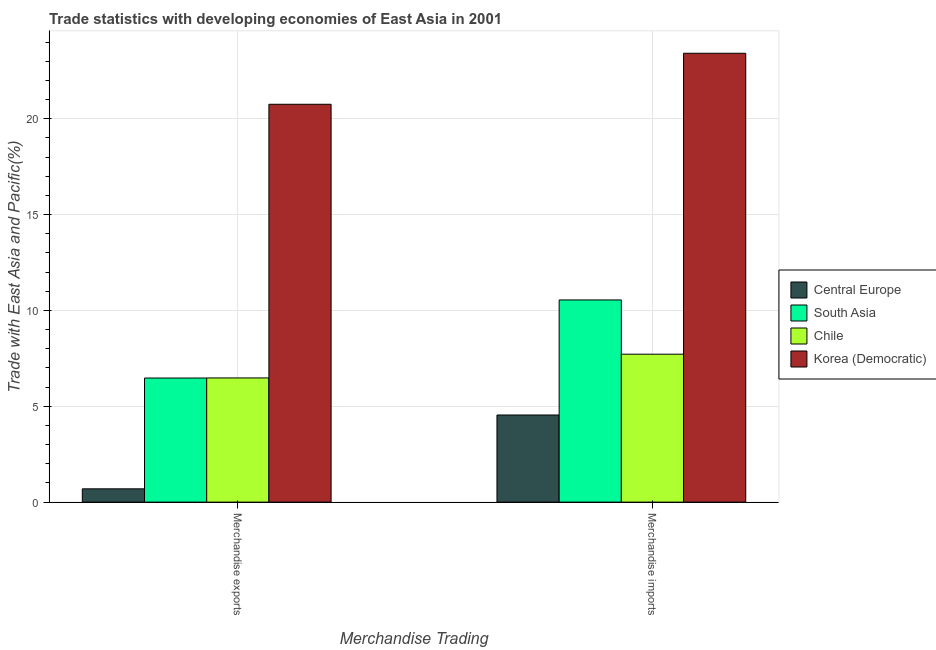Are the number of bars on each tick of the X-axis equal?
Your answer should be compact. Yes. How many bars are there on the 2nd tick from the left?
Make the answer very short. 4. How many bars are there on the 1st tick from the right?
Ensure brevity in your answer.  4. What is the merchandise imports in Chile?
Keep it short and to the point. 7.72. Across all countries, what is the maximum merchandise imports?
Offer a terse response. 23.42. Across all countries, what is the minimum merchandise exports?
Make the answer very short. 0.69. In which country was the merchandise exports maximum?
Your answer should be compact. Korea (Democratic). In which country was the merchandise imports minimum?
Provide a short and direct response. Central Europe. What is the total merchandise imports in the graph?
Offer a terse response. 46.22. What is the difference between the merchandise exports in South Asia and that in Central Europe?
Ensure brevity in your answer.  5.78. What is the difference between the merchandise exports in Central Europe and the merchandise imports in South Asia?
Provide a succinct answer. -9.85. What is the average merchandise exports per country?
Give a very brief answer. 8.6. What is the difference between the merchandise exports and merchandise imports in South Asia?
Ensure brevity in your answer.  -4.07. In how many countries, is the merchandise exports greater than 21 %?
Provide a succinct answer. 0. What is the ratio of the merchandise imports in Chile to that in Korea (Democratic)?
Your answer should be very brief. 0.33. Is the merchandise exports in Korea (Democratic) less than that in Chile?
Provide a succinct answer. No. In how many countries, is the merchandise exports greater than the average merchandise exports taken over all countries?
Provide a succinct answer. 1. What does the 1st bar from the right in Merchandise exports represents?
Offer a very short reply. Korea (Democratic). Are all the bars in the graph horizontal?
Your response must be concise. No. What is the difference between two consecutive major ticks on the Y-axis?
Ensure brevity in your answer.  5. Does the graph contain any zero values?
Give a very brief answer. No. Does the graph contain grids?
Ensure brevity in your answer.  Yes. Where does the legend appear in the graph?
Make the answer very short. Center right. How are the legend labels stacked?
Your answer should be very brief. Vertical. What is the title of the graph?
Offer a very short reply. Trade statistics with developing economies of East Asia in 2001. What is the label or title of the X-axis?
Make the answer very short. Merchandise Trading. What is the label or title of the Y-axis?
Offer a terse response. Trade with East Asia and Pacific(%). What is the Trade with East Asia and Pacific(%) in Central Europe in Merchandise exports?
Offer a very short reply. 0.69. What is the Trade with East Asia and Pacific(%) of South Asia in Merchandise exports?
Provide a short and direct response. 6.47. What is the Trade with East Asia and Pacific(%) in Chile in Merchandise exports?
Offer a terse response. 6.48. What is the Trade with East Asia and Pacific(%) of Korea (Democratic) in Merchandise exports?
Provide a short and direct response. 20.75. What is the Trade with East Asia and Pacific(%) in Central Europe in Merchandise imports?
Your response must be concise. 4.55. What is the Trade with East Asia and Pacific(%) in South Asia in Merchandise imports?
Ensure brevity in your answer.  10.55. What is the Trade with East Asia and Pacific(%) in Chile in Merchandise imports?
Make the answer very short. 7.72. What is the Trade with East Asia and Pacific(%) in Korea (Democratic) in Merchandise imports?
Make the answer very short. 23.42. Across all Merchandise Trading, what is the maximum Trade with East Asia and Pacific(%) in Central Europe?
Keep it short and to the point. 4.55. Across all Merchandise Trading, what is the maximum Trade with East Asia and Pacific(%) of South Asia?
Keep it short and to the point. 10.55. Across all Merchandise Trading, what is the maximum Trade with East Asia and Pacific(%) in Chile?
Your answer should be compact. 7.72. Across all Merchandise Trading, what is the maximum Trade with East Asia and Pacific(%) in Korea (Democratic)?
Your answer should be compact. 23.42. Across all Merchandise Trading, what is the minimum Trade with East Asia and Pacific(%) in Central Europe?
Your answer should be compact. 0.69. Across all Merchandise Trading, what is the minimum Trade with East Asia and Pacific(%) in South Asia?
Keep it short and to the point. 6.47. Across all Merchandise Trading, what is the minimum Trade with East Asia and Pacific(%) in Chile?
Offer a very short reply. 6.48. Across all Merchandise Trading, what is the minimum Trade with East Asia and Pacific(%) of Korea (Democratic)?
Your answer should be compact. 20.75. What is the total Trade with East Asia and Pacific(%) of Central Europe in the graph?
Offer a terse response. 5.24. What is the total Trade with East Asia and Pacific(%) in South Asia in the graph?
Your answer should be very brief. 17.02. What is the total Trade with East Asia and Pacific(%) of Chile in the graph?
Your answer should be very brief. 14.19. What is the total Trade with East Asia and Pacific(%) in Korea (Democratic) in the graph?
Give a very brief answer. 44.17. What is the difference between the Trade with East Asia and Pacific(%) in Central Europe in Merchandise exports and that in Merchandise imports?
Offer a very short reply. -3.85. What is the difference between the Trade with East Asia and Pacific(%) in South Asia in Merchandise exports and that in Merchandise imports?
Keep it short and to the point. -4.07. What is the difference between the Trade with East Asia and Pacific(%) in Chile in Merchandise exports and that in Merchandise imports?
Give a very brief answer. -1.24. What is the difference between the Trade with East Asia and Pacific(%) in Korea (Democratic) in Merchandise exports and that in Merchandise imports?
Offer a very short reply. -2.66. What is the difference between the Trade with East Asia and Pacific(%) of Central Europe in Merchandise exports and the Trade with East Asia and Pacific(%) of South Asia in Merchandise imports?
Make the answer very short. -9.85. What is the difference between the Trade with East Asia and Pacific(%) in Central Europe in Merchandise exports and the Trade with East Asia and Pacific(%) in Chile in Merchandise imports?
Offer a very short reply. -7.02. What is the difference between the Trade with East Asia and Pacific(%) of Central Europe in Merchandise exports and the Trade with East Asia and Pacific(%) of Korea (Democratic) in Merchandise imports?
Provide a short and direct response. -22.72. What is the difference between the Trade with East Asia and Pacific(%) in South Asia in Merchandise exports and the Trade with East Asia and Pacific(%) in Chile in Merchandise imports?
Your answer should be compact. -1.24. What is the difference between the Trade with East Asia and Pacific(%) in South Asia in Merchandise exports and the Trade with East Asia and Pacific(%) in Korea (Democratic) in Merchandise imports?
Provide a short and direct response. -16.94. What is the difference between the Trade with East Asia and Pacific(%) in Chile in Merchandise exports and the Trade with East Asia and Pacific(%) in Korea (Democratic) in Merchandise imports?
Offer a terse response. -16.94. What is the average Trade with East Asia and Pacific(%) in Central Europe per Merchandise Trading?
Your answer should be compact. 2.62. What is the average Trade with East Asia and Pacific(%) in South Asia per Merchandise Trading?
Ensure brevity in your answer.  8.51. What is the average Trade with East Asia and Pacific(%) in Chile per Merchandise Trading?
Provide a succinct answer. 7.1. What is the average Trade with East Asia and Pacific(%) of Korea (Democratic) per Merchandise Trading?
Give a very brief answer. 22.08. What is the difference between the Trade with East Asia and Pacific(%) in Central Europe and Trade with East Asia and Pacific(%) in South Asia in Merchandise exports?
Your answer should be compact. -5.78. What is the difference between the Trade with East Asia and Pacific(%) of Central Europe and Trade with East Asia and Pacific(%) of Chile in Merchandise exports?
Offer a very short reply. -5.78. What is the difference between the Trade with East Asia and Pacific(%) in Central Europe and Trade with East Asia and Pacific(%) in Korea (Democratic) in Merchandise exports?
Your answer should be compact. -20.06. What is the difference between the Trade with East Asia and Pacific(%) of South Asia and Trade with East Asia and Pacific(%) of Chile in Merchandise exports?
Your response must be concise. -0. What is the difference between the Trade with East Asia and Pacific(%) in South Asia and Trade with East Asia and Pacific(%) in Korea (Democratic) in Merchandise exports?
Offer a very short reply. -14.28. What is the difference between the Trade with East Asia and Pacific(%) of Chile and Trade with East Asia and Pacific(%) of Korea (Democratic) in Merchandise exports?
Your response must be concise. -14.28. What is the difference between the Trade with East Asia and Pacific(%) in Central Europe and Trade with East Asia and Pacific(%) in South Asia in Merchandise imports?
Offer a terse response. -6. What is the difference between the Trade with East Asia and Pacific(%) in Central Europe and Trade with East Asia and Pacific(%) in Chile in Merchandise imports?
Make the answer very short. -3.17. What is the difference between the Trade with East Asia and Pacific(%) in Central Europe and Trade with East Asia and Pacific(%) in Korea (Democratic) in Merchandise imports?
Make the answer very short. -18.87. What is the difference between the Trade with East Asia and Pacific(%) in South Asia and Trade with East Asia and Pacific(%) in Chile in Merchandise imports?
Your answer should be very brief. 2.83. What is the difference between the Trade with East Asia and Pacific(%) of South Asia and Trade with East Asia and Pacific(%) of Korea (Democratic) in Merchandise imports?
Provide a short and direct response. -12.87. What is the difference between the Trade with East Asia and Pacific(%) of Chile and Trade with East Asia and Pacific(%) of Korea (Democratic) in Merchandise imports?
Give a very brief answer. -15.7. What is the ratio of the Trade with East Asia and Pacific(%) in Central Europe in Merchandise exports to that in Merchandise imports?
Your answer should be compact. 0.15. What is the ratio of the Trade with East Asia and Pacific(%) in South Asia in Merchandise exports to that in Merchandise imports?
Provide a succinct answer. 0.61. What is the ratio of the Trade with East Asia and Pacific(%) in Chile in Merchandise exports to that in Merchandise imports?
Offer a very short reply. 0.84. What is the ratio of the Trade with East Asia and Pacific(%) of Korea (Democratic) in Merchandise exports to that in Merchandise imports?
Offer a very short reply. 0.89. What is the difference between the highest and the second highest Trade with East Asia and Pacific(%) of Central Europe?
Ensure brevity in your answer.  3.85. What is the difference between the highest and the second highest Trade with East Asia and Pacific(%) of South Asia?
Ensure brevity in your answer.  4.07. What is the difference between the highest and the second highest Trade with East Asia and Pacific(%) of Chile?
Your answer should be very brief. 1.24. What is the difference between the highest and the second highest Trade with East Asia and Pacific(%) in Korea (Democratic)?
Offer a very short reply. 2.66. What is the difference between the highest and the lowest Trade with East Asia and Pacific(%) in Central Europe?
Your answer should be compact. 3.85. What is the difference between the highest and the lowest Trade with East Asia and Pacific(%) in South Asia?
Provide a short and direct response. 4.07. What is the difference between the highest and the lowest Trade with East Asia and Pacific(%) of Chile?
Ensure brevity in your answer.  1.24. What is the difference between the highest and the lowest Trade with East Asia and Pacific(%) in Korea (Democratic)?
Keep it short and to the point. 2.66. 